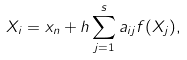Convert formula to latex. <formula><loc_0><loc_0><loc_500><loc_500>X _ { i } = x _ { n } + h \sum _ { j = 1 } ^ { s } a _ { i j } f ( X _ { j } ) ,</formula> 